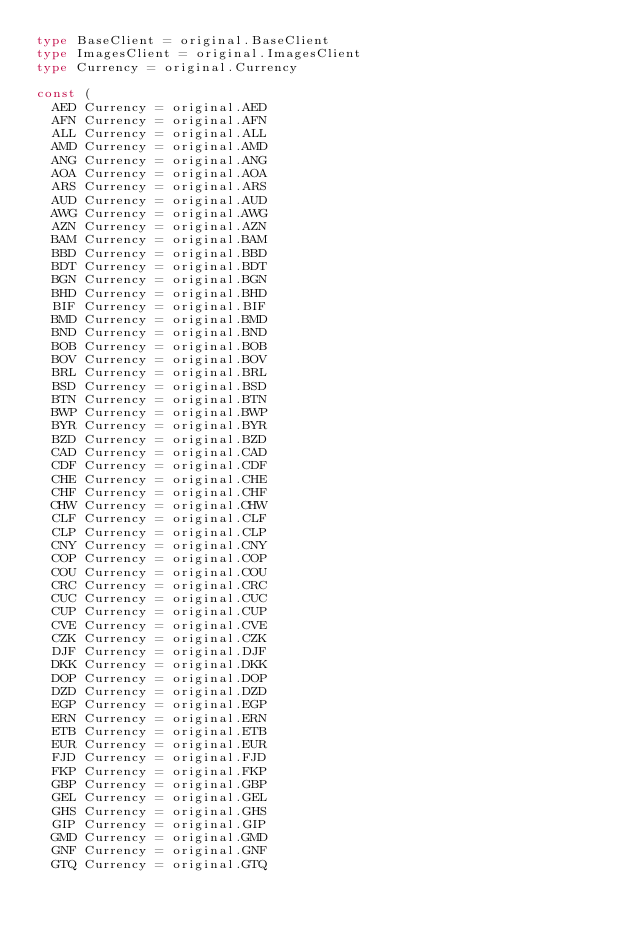<code> <loc_0><loc_0><loc_500><loc_500><_Go_>type BaseClient = original.BaseClient
type ImagesClient = original.ImagesClient
type Currency = original.Currency

const (
	AED Currency = original.AED
	AFN Currency = original.AFN
	ALL Currency = original.ALL
	AMD Currency = original.AMD
	ANG Currency = original.ANG
	AOA Currency = original.AOA
	ARS Currency = original.ARS
	AUD Currency = original.AUD
	AWG Currency = original.AWG
	AZN Currency = original.AZN
	BAM Currency = original.BAM
	BBD Currency = original.BBD
	BDT Currency = original.BDT
	BGN Currency = original.BGN
	BHD Currency = original.BHD
	BIF Currency = original.BIF
	BMD Currency = original.BMD
	BND Currency = original.BND
	BOB Currency = original.BOB
	BOV Currency = original.BOV
	BRL Currency = original.BRL
	BSD Currency = original.BSD
	BTN Currency = original.BTN
	BWP Currency = original.BWP
	BYR Currency = original.BYR
	BZD Currency = original.BZD
	CAD Currency = original.CAD
	CDF Currency = original.CDF
	CHE Currency = original.CHE
	CHF Currency = original.CHF
	CHW Currency = original.CHW
	CLF Currency = original.CLF
	CLP Currency = original.CLP
	CNY Currency = original.CNY
	COP Currency = original.COP
	COU Currency = original.COU
	CRC Currency = original.CRC
	CUC Currency = original.CUC
	CUP Currency = original.CUP
	CVE Currency = original.CVE
	CZK Currency = original.CZK
	DJF Currency = original.DJF
	DKK Currency = original.DKK
	DOP Currency = original.DOP
	DZD Currency = original.DZD
	EGP Currency = original.EGP
	ERN Currency = original.ERN
	ETB Currency = original.ETB
	EUR Currency = original.EUR
	FJD Currency = original.FJD
	FKP Currency = original.FKP
	GBP Currency = original.GBP
	GEL Currency = original.GEL
	GHS Currency = original.GHS
	GIP Currency = original.GIP
	GMD Currency = original.GMD
	GNF Currency = original.GNF
	GTQ Currency = original.GTQ</code> 